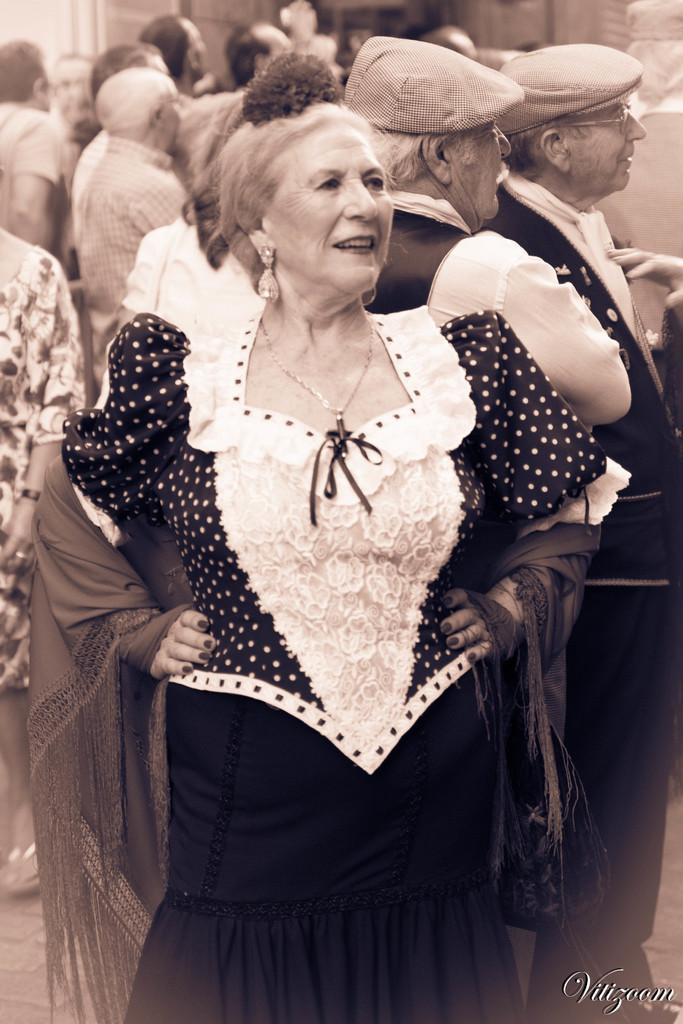Who or what can be seen in the image? There are people in the image. What are some of the people wearing? Some people are wearing caps. Is there any text present in the image? Yes, there is text at the bottom of the image. Can you see any sea creatures in the image? There are no sea creatures present in the image; it features people and text. Is there a sister in the image? The provided facts do not mention a sister, so we cannot determine if there is one in the image. 